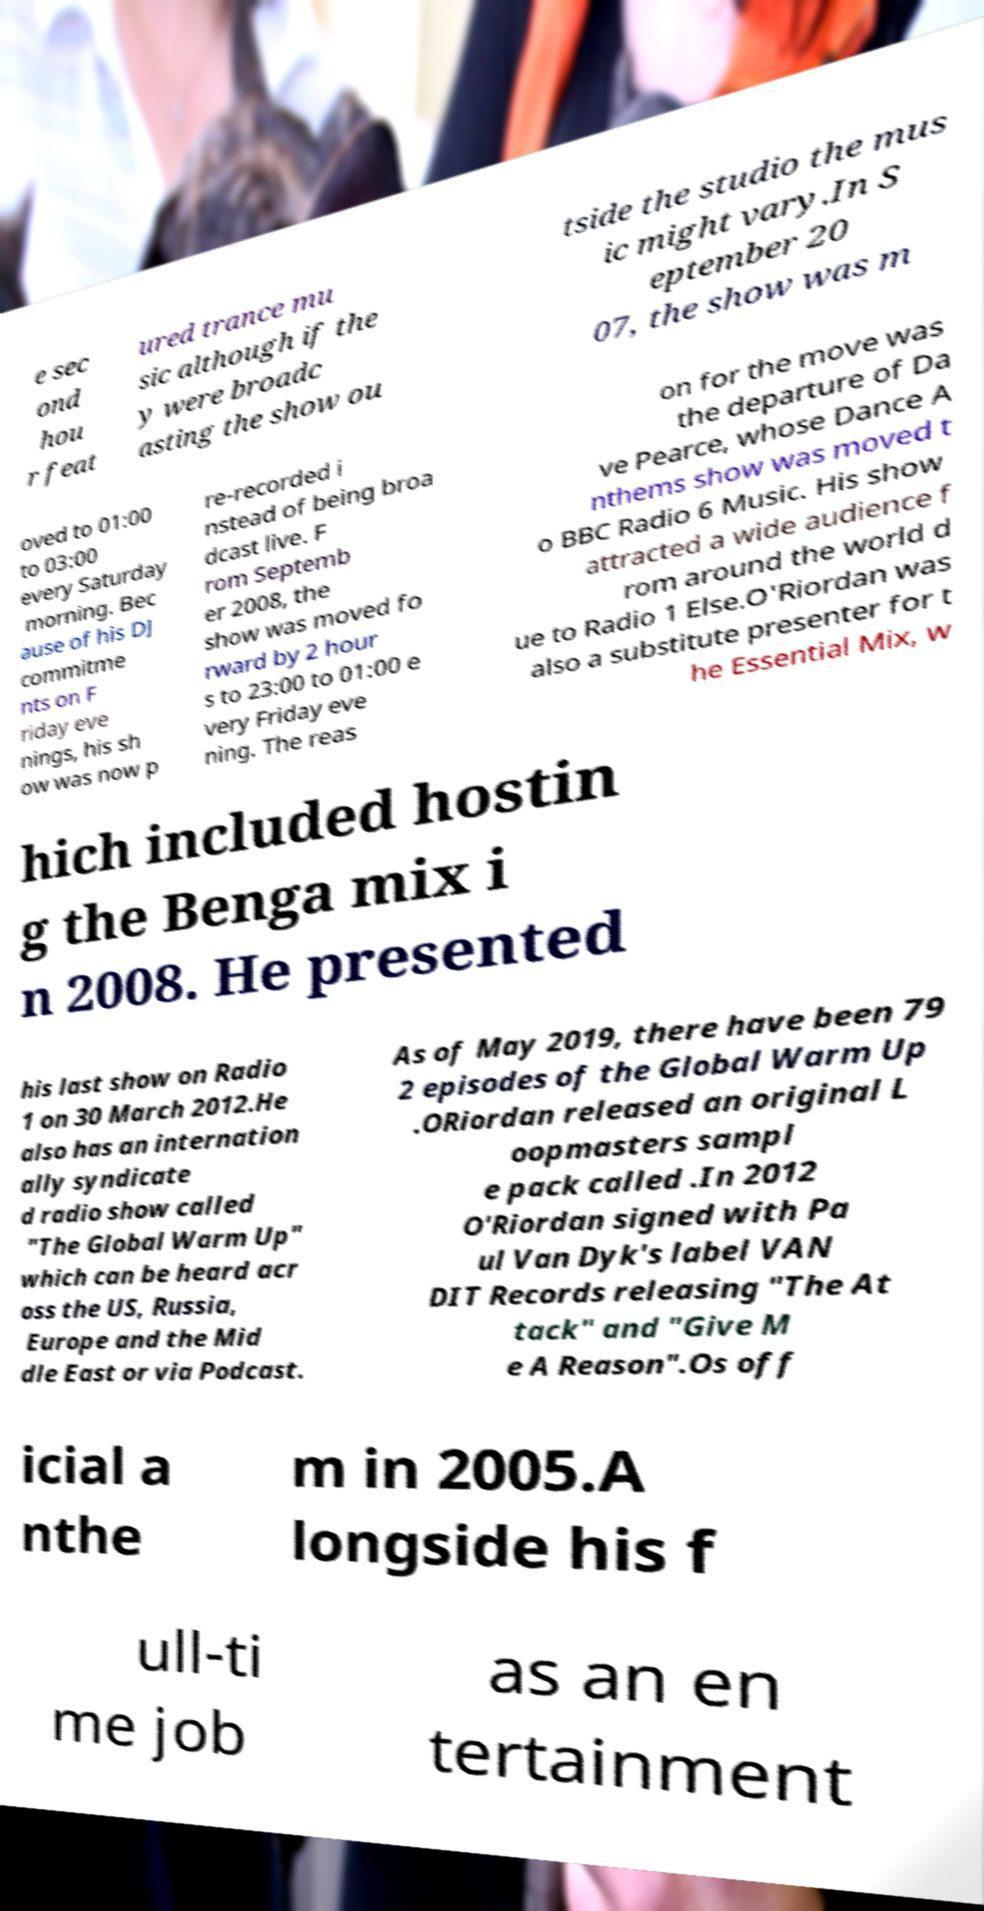There's text embedded in this image that I need extracted. Can you transcribe it verbatim? e sec ond hou r feat ured trance mu sic although if the y were broadc asting the show ou tside the studio the mus ic might vary.In S eptember 20 07, the show was m oved to 01:00 to 03:00 every Saturday morning. Bec ause of his DJ commitme nts on F riday eve nings, his sh ow was now p re-recorded i nstead of being broa dcast live. F rom Septemb er 2008, the show was moved fo rward by 2 hour s to 23:00 to 01:00 e very Friday eve ning. The reas on for the move was the departure of Da ve Pearce, whose Dance A nthems show was moved t o BBC Radio 6 Music. His show attracted a wide audience f rom around the world d ue to Radio 1 Else.O'Riordan was also a substitute presenter for t he Essential Mix, w hich included hostin g the Benga mix i n 2008. He presented his last show on Radio 1 on 30 March 2012.He also has an internation ally syndicate d radio show called "The Global Warm Up" which can be heard acr oss the US, Russia, Europe and the Mid dle East or via Podcast. As of May 2019, there have been 79 2 episodes of the Global Warm Up .ORiordan released an original L oopmasters sampl e pack called .In 2012 O'Riordan signed with Pa ul Van Dyk's label VAN DIT Records releasing "The At tack" and "Give M e A Reason".Os off icial a nthe m in 2005.A longside his f ull-ti me job as an en tertainment 